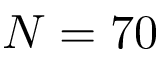<formula> <loc_0><loc_0><loc_500><loc_500>N = 7 0</formula> 